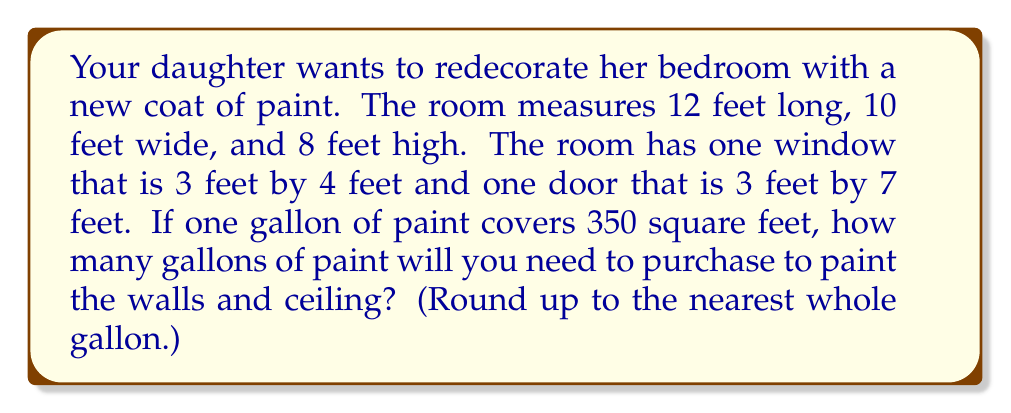Can you solve this math problem? Let's approach this step-by-step:

1. Calculate the total surface area to be painted:

   a. Walls:
      - Two long walls: $2 \times (12 \text{ ft} \times 8 \text{ ft}) = 192 \text{ sq ft}$
      - Two short walls: $2 \times (10 \text{ ft} \times 8 \text{ ft}) = 160 \text{ sq ft}$
   b. Ceiling: $12 \text{ ft} \times 10 \text{ ft} = 120 \text{ sq ft}$

   Total surface area: $192 + 160 + 120 = 472 \text{ sq ft}$

2. Subtract the area of the window and door:
   - Window: $3 \text{ ft} \times 4 \text{ ft} = 12 \text{ sq ft}$
   - Door: $3 \text{ ft} \times 7 \text{ ft} = 21 \text{ sq ft}$

   Area to subtract: $12 + 21 = 33 \text{ sq ft}$

3. Calculate the actual area to be painted:
   $472 \text{ sq ft} - 33 \text{ sq ft} = 439 \text{ sq ft}$

4. Determine the number of gallons needed:
   $\frac{439 \text{ sq ft}}{350 \text{ sq ft/gallon}} \approx 1.25 \text{ gallons}$

5. Round up to the nearest whole gallon:
   $1.25 \text{ gallons} \rightarrow 2 \text{ gallons}$

Therefore, you will need to purchase 2 gallons of paint to cover all the walls and ceiling in your daughter's bedroom.
Answer: 2 gallons 